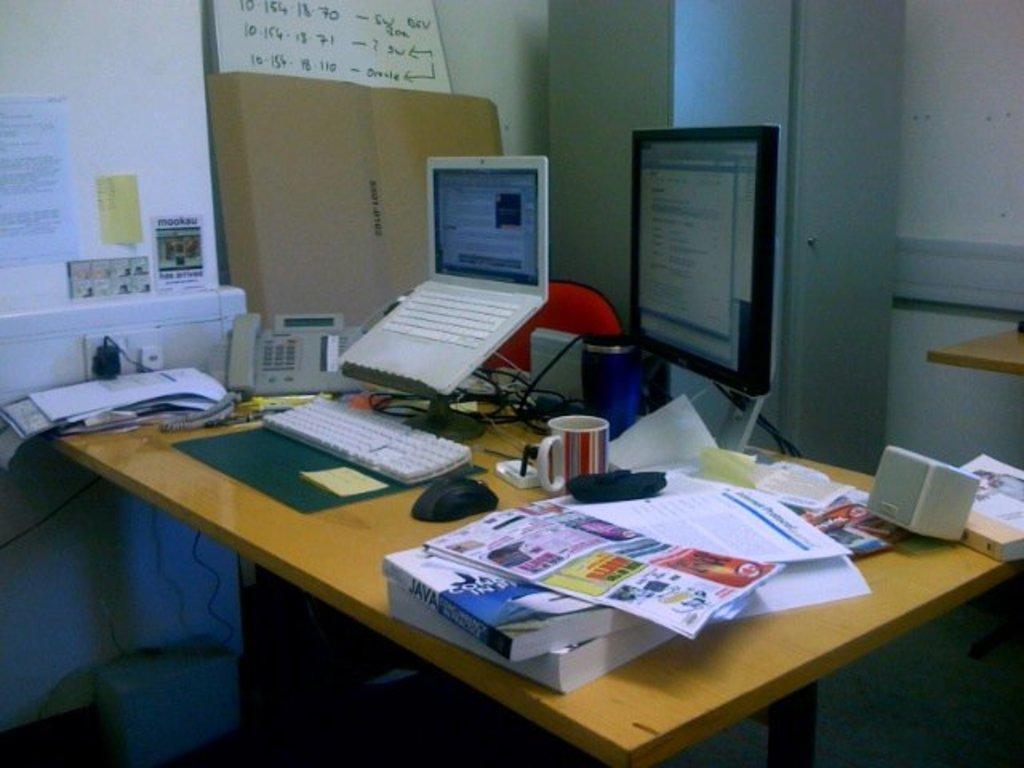Describe this image in one or two sentences. On the table I can see the laptop, computer screen, keyboard, mouse, cup, speakers, telephone, papers, books, pen, cables, mat and other objects. On the left I can see the charger which is placed on the socket, beside that I can see the posters and cotton box. In the top left there is a white board which is placed on this cotton box. On the right I can see another table which is placed near to the wall, beside that I can see the pillar. In the bottom left I can see a blue color box which is placed on the floor. 